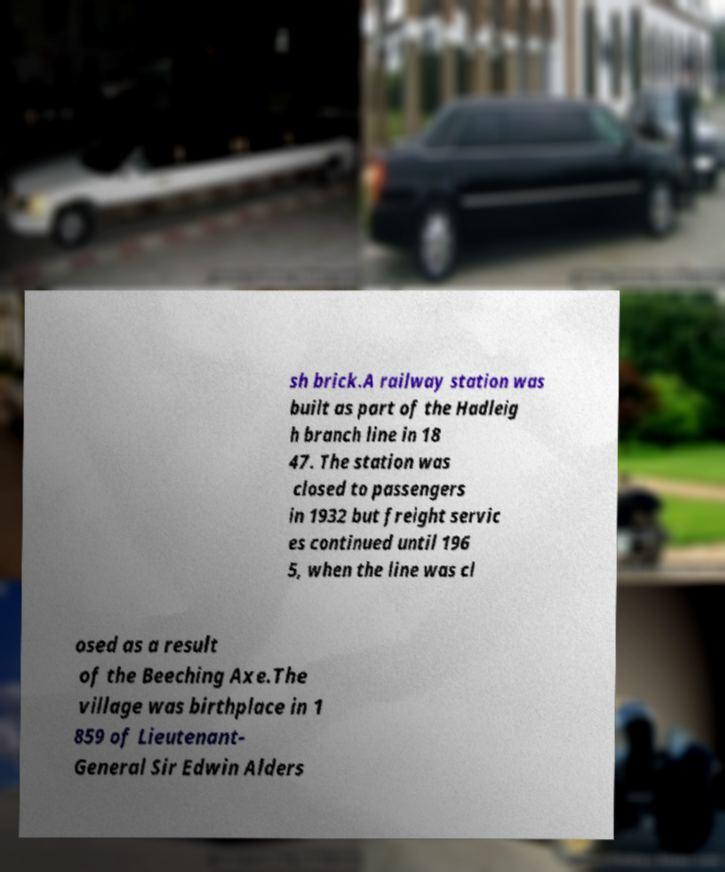I need the written content from this picture converted into text. Can you do that? sh brick.A railway station was built as part of the Hadleig h branch line in 18 47. The station was closed to passengers in 1932 but freight servic es continued until 196 5, when the line was cl osed as a result of the Beeching Axe.The village was birthplace in 1 859 of Lieutenant- General Sir Edwin Alders 